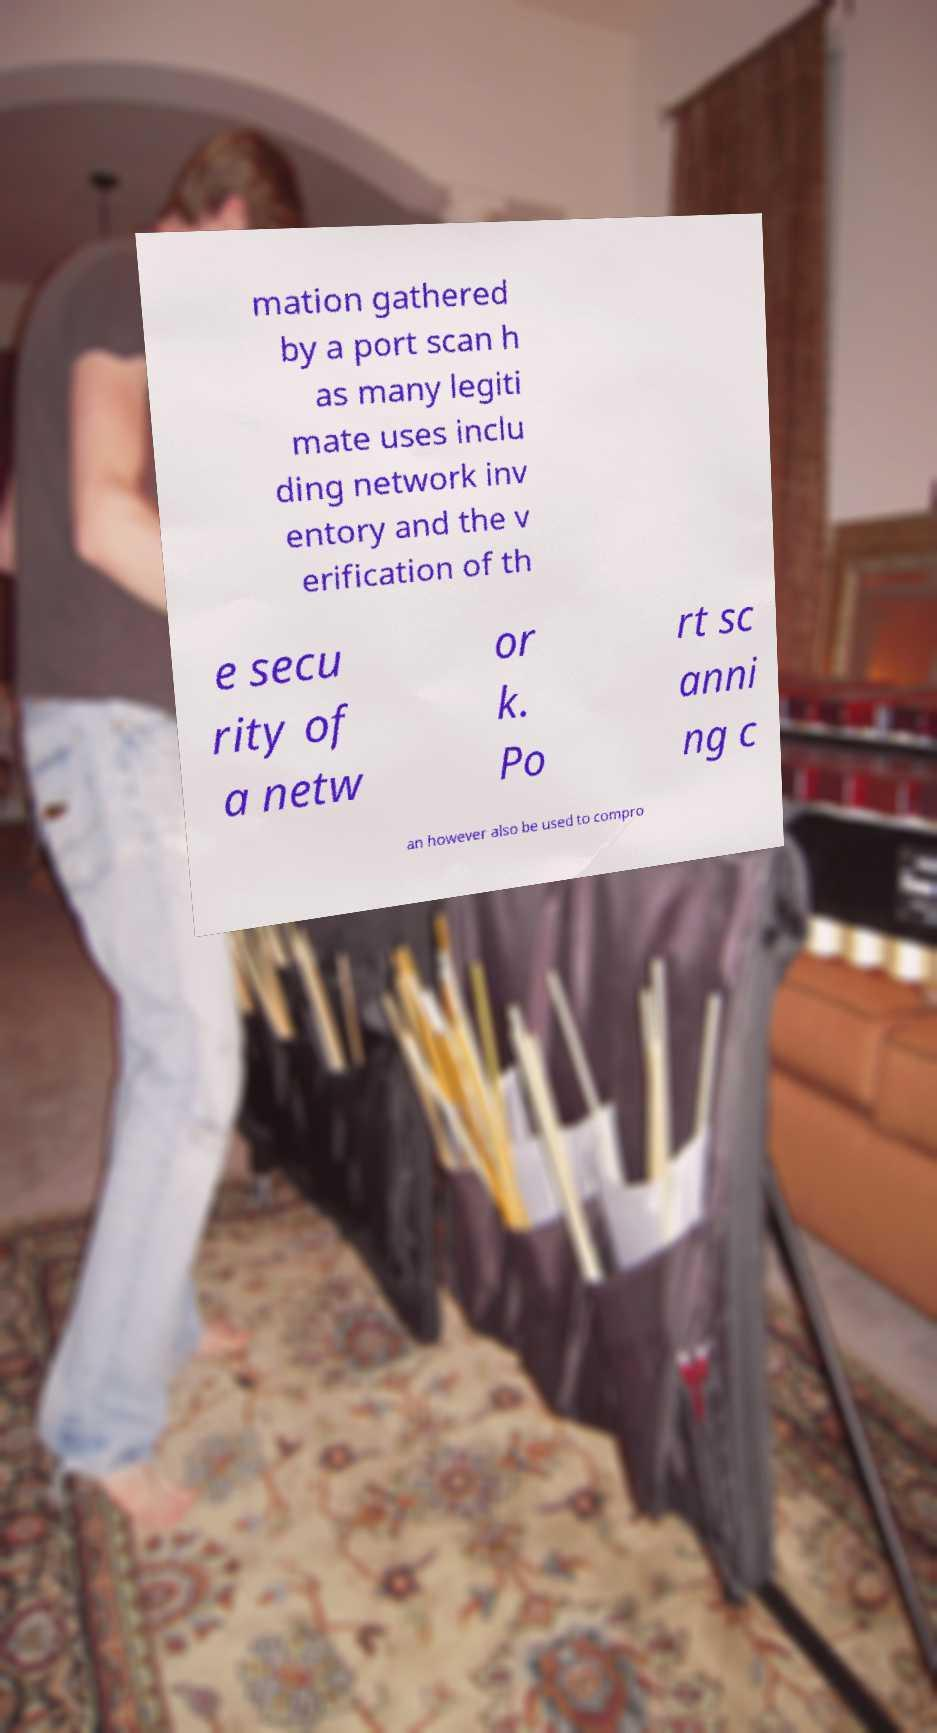Can you read and provide the text displayed in the image?This photo seems to have some interesting text. Can you extract and type it out for me? mation gathered by a port scan h as many legiti mate uses inclu ding network inv entory and the v erification of th e secu rity of a netw or k. Po rt sc anni ng c an however also be used to compro 